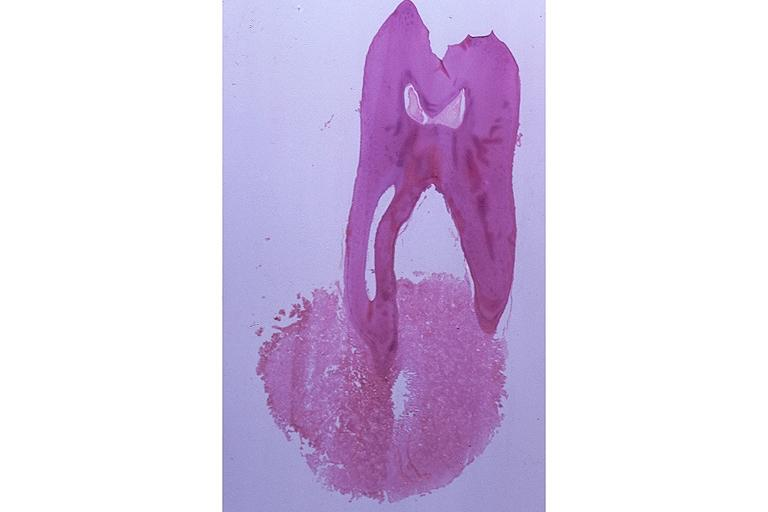where is this?
Answer the question using a single word or phrase. Oral 